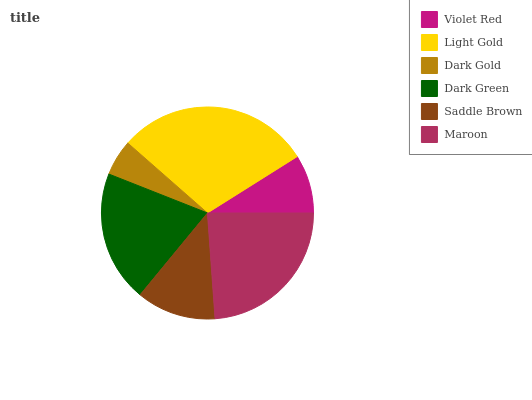Is Dark Gold the minimum?
Answer yes or no. Yes. Is Light Gold the maximum?
Answer yes or no. Yes. Is Light Gold the minimum?
Answer yes or no. No. Is Dark Gold the maximum?
Answer yes or no. No. Is Light Gold greater than Dark Gold?
Answer yes or no. Yes. Is Dark Gold less than Light Gold?
Answer yes or no. Yes. Is Dark Gold greater than Light Gold?
Answer yes or no. No. Is Light Gold less than Dark Gold?
Answer yes or no. No. Is Dark Green the high median?
Answer yes or no. Yes. Is Saddle Brown the low median?
Answer yes or no. Yes. Is Maroon the high median?
Answer yes or no. No. Is Dark Green the low median?
Answer yes or no. No. 